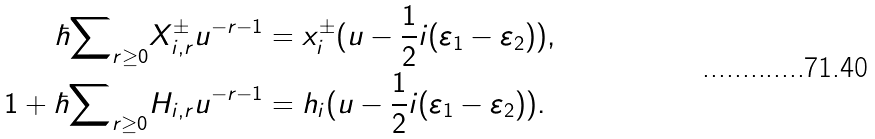<formula> <loc_0><loc_0><loc_500><loc_500>\hbar { \sum } _ { r \geq 0 } X _ { i , r } ^ { \pm } u ^ { - r - 1 } & = x _ { i } ^ { \pm } ( u - \frac { 1 } { 2 } i ( \varepsilon _ { 1 } - \varepsilon _ { 2 } ) ) , \\ 1 + \hbar { \sum } _ { r \geq 0 } H _ { i , r } u ^ { - r - 1 } & = h _ { i } ( u - \frac { 1 } { 2 } i ( \varepsilon _ { 1 } - \varepsilon _ { 2 } ) ) .</formula> 